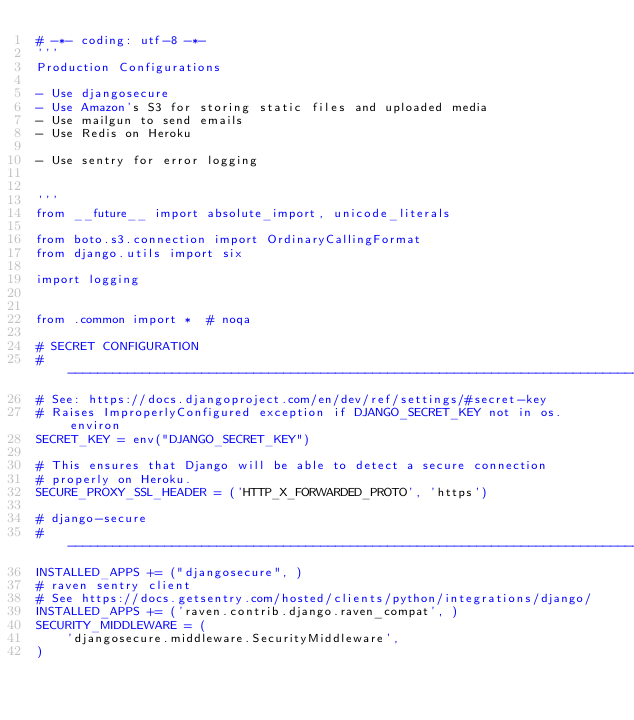<code> <loc_0><loc_0><loc_500><loc_500><_Python_># -*- coding: utf-8 -*-
'''
Production Configurations

- Use djangosecure
- Use Amazon's S3 for storing static files and uploaded media
- Use mailgun to send emails
- Use Redis on Heroku

- Use sentry for error logging


'''
from __future__ import absolute_import, unicode_literals

from boto.s3.connection import OrdinaryCallingFormat
from django.utils import six

import logging


from .common import *  # noqa

# SECRET CONFIGURATION
# ------------------------------------------------------------------------------
# See: https://docs.djangoproject.com/en/dev/ref/settings/#secret-key
# Raises ImproperlyConfigured exception if DJANGO_SECRET_KEY not in os.environ
SECRET_KEY = env("DJANGO_SECRET_KEY")

# This ensures that Django will be able to detect a secure connection
# properly on Heroku.
SECURE_PROXY_SSL_HEADER = ('HTTP_X_FORWARDED_PROTO', 'https')

# django-secure
# ------------------------------------------------------------------------------
INSTALLED_APPS += ("djangosecure", )
# raven sentry client
# See https://docs.getsentry.com/hosted/clients/python/integrations/django/
INSTALLED_APPS += ('raven.contrib.django.raven_compat', )
SECURITY_MIDDLEWARE = (
    'djangosecure.middleware.SecurityMiddleware',
)</code> 